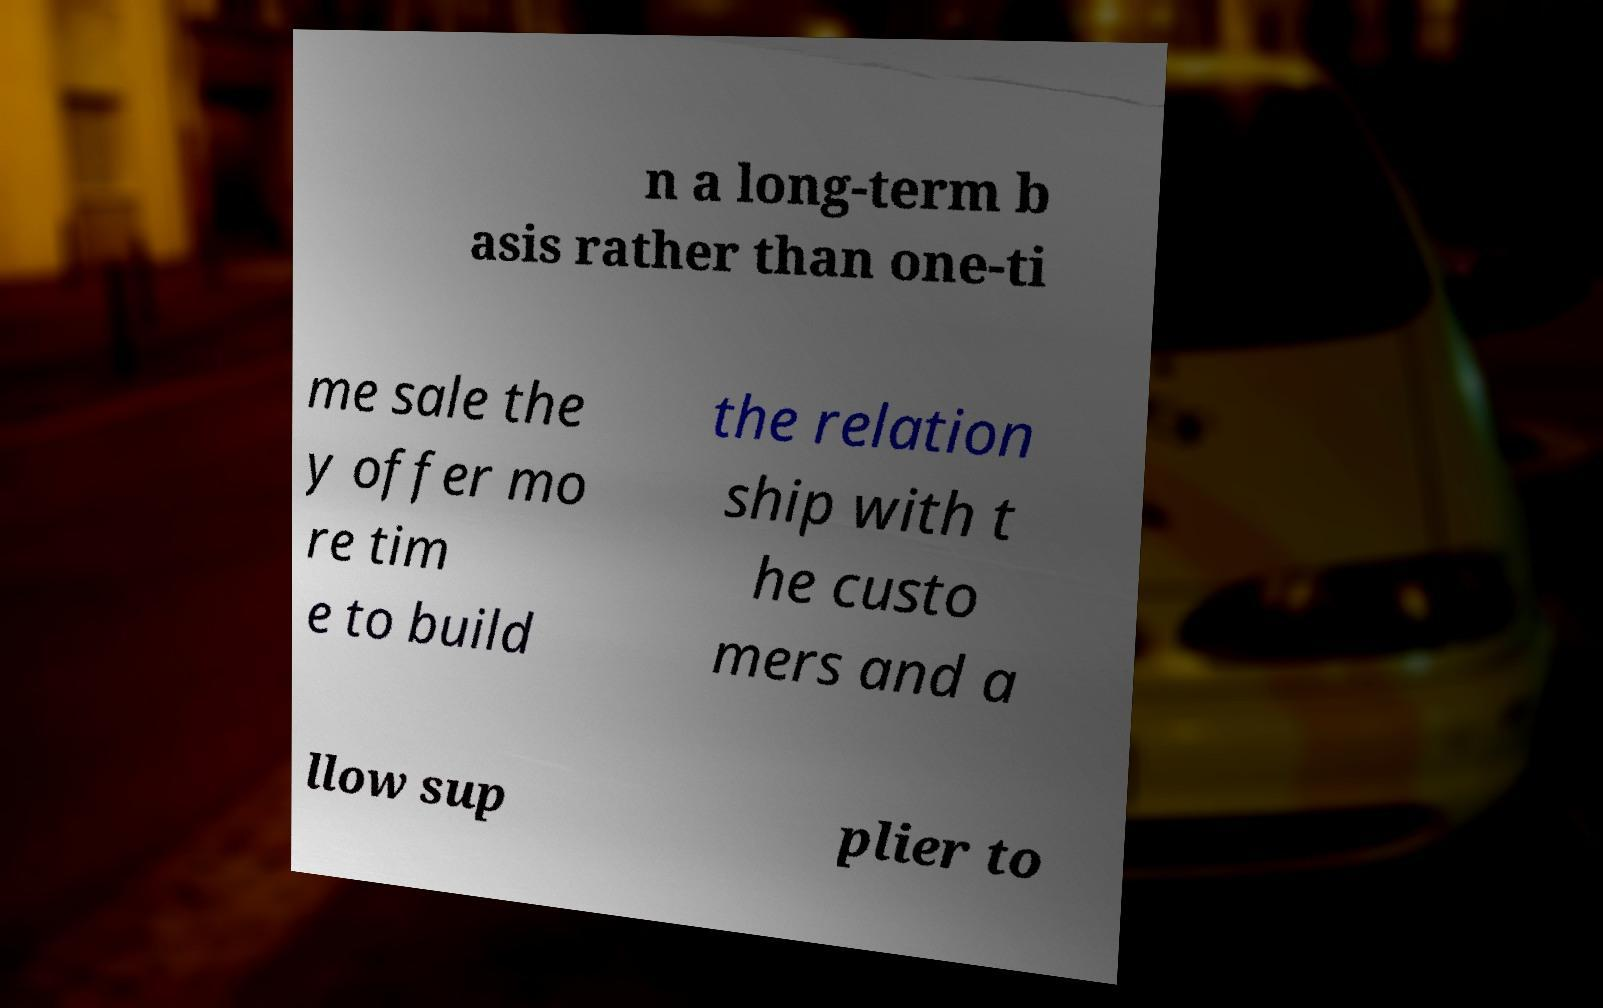Please read and relay the text visible in this image. What does it say? n a long-term b asis rather than one-ti me sale the y offer mo re tim e to build the relation ship with t he custo mers and a llow sup plier to 